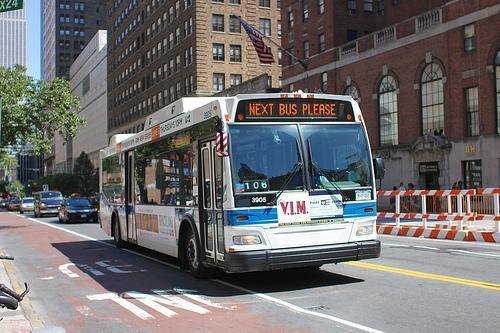How many buses are in the picture?
Give a very brief answer. 1. 